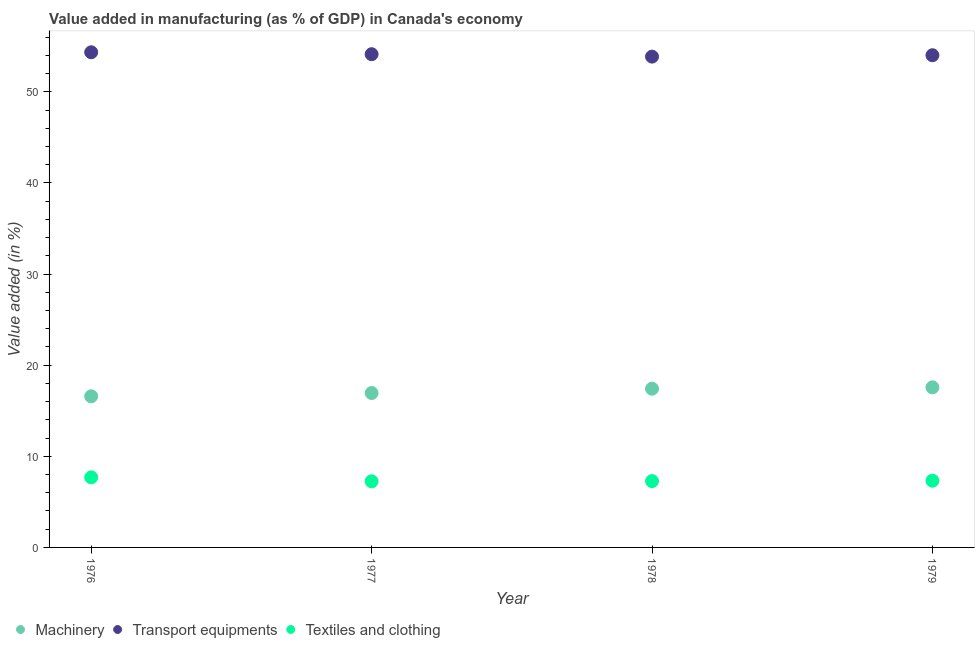How many different coloured dotlines are there?
Keep it short and to the point. 3. Is the number of dotlines equal to the number of legend labels?
Provide a succinct answer. Yes. What is the value added in manufacturing transport equipments in 1979?
Offer a terse response. 54.01. Across all years, what is the maximum value added in manufacturing textile and clothing?
Offer a terse response. 7.69. Across all years, what is the minimum value added in manufacturing textile and clothing?
Provide a succinct answer. 7.26. In which year was the value added in manufacturing machinery maximum?
Give a very brief answer. 1979. In which year was the value added in manufacturing transport equipments minimum?
Offer a terse response. 1978. What is the total value added in manufacturing transport equipments in the graph?
Make the answer very short. 216.33. What is the difference between the value added in manufacturing transport equipments in 1978 and that in 1979?
Ensure brevity in your answer.  -0.15. What is the difference between the value added in manufacturing machinery in 1978 and the value added in manufacturing transport equipments in 1977?
Offer a terse response. -36.71. What is the average value added in manufacturing transport equipments per year?
Ensure brevity in your answer.  54.08. In the year 1979, what is the difference between the value added in manufacturing textile and clothing and value added in manufacturing transport equipments?
Your answer should be compact. -46.69. In how many years, is the value added in manufacturing textile and clothing greater than 48 %?
Give a very brief answer. 0. What is the ratio of the value added in manufacturing textile and clothing in 1976 to that in 1977?
Your response must be concise. 1.06. Is the value added in manufacturing machinery in 1976 less than that in 1977?
Your answer should be very brief. Yes. What is the difference between the highest and the second highest value added in manufacturing textile and clothing?
Offer a very short reply. 0.36. What is the difference between the highest and the lowest value added in manufacturing machinery?
Make the answer very short. 0.98. In how many years, is the value added in manufacturing transport equipments greater than the average value added in manufacturing transport equipments taken over all years?
Offer a very short reply. 2. Is the sum of the value added in manufacturing transport equipments in 1978 and 1979 greater than the maximum value added in manufacturing machinery across all years?
Your answer should be very brief. Yes. Is it the case that in every year, the sum of the value added in manufacturing machinery and value added in manufacturing transport equipments is greater than the value added in manufacturing textile and clothing?
Offer a terse response. Yes. Does the value added in manufacturing textile and clothing monotonically increase over the years?
Provide a succinct answer. No. Is the value added in manufacturing textile and clothing strictly greater than the value added in manufacturing machinery over the years?
Provide a succinct answer. No. How many years are there in the graph?
Your answer should be compact. 4. What is the difference between two consecutive major ticks on the Y-axis?
Your answer should be compact. 10. Are the values on the major ticks of Y-axis written in scientific E-notation?
Ensure brevity in your answer.  No. Where does the legend appear in the graph?
Ensure brevity in your answer.  Bottom left. How are the legend labels stacked?
Make the answer very short. Horizontal. What is the title of the graph?
Provide a short and direct response. Value added in manufacturing (as % of GDP) in Canada's economy. What is the label or title of the Y-axis?
Ensure brevity in your answer.  Value added (in %). What is the Value added (in %) in Machinery in 1976?
Give a very brief answer. 16.59. What is the Value added (in %) of Transport equipments in 1976?
Offer a very short reply. 54.34. What is the Value added (in %) in Textiles and clothing in 1976?
Make the answer very short. 7.69. What is the Value added (in %) of Machinery in 1977?
Give a very brief answer. 16.94. What is the Value added (in %) of Transport equipments in 1977?
Your answer should be compact. 54.13. What is the Value added (in %) in Textiles and clothing in 1977?
Offer a terse response. 7.26. What is the Value added (in %) of Machinery in 1978?
Your answer should be very brief. 17.42. What is the Value added (in %) in Transport equipments in 1978?
Ensure brevity in your answer.  53.86. What is the Value added (in %) of Textiles and clothing in 1978?
Offer a terse response. 7.28. What is the Value added (in %) in Machinery in 1979?
Give a very brief answer. 17.57. What is the Value added (in %) in Transport equipments in 1979?
Ensure brevity in your answer.  54.01. What is the Value added (in %) of Textiles and clothing in 1979?
Your answer should be compact. 7.32. Across all years, what is the maximum Value added (in %) in Machinery?
Provide a succinct answer. 17.57. Across all years, what is the maximum Value added (in %) in Transport equipments?
Make the answer very short. 54.34. Across all years, what is the maximum Value added (in %) of Textiles and clothing?
Keep it short and to the point. 7.69. Across all years, what is the minimum Value added (in %) in Machinery?
Give a very brief answer. 16.59. Across all years, what is the minimum Value added (in %) in Transport equipments?
Offer a very short reply. 53.86. Across all years, what is the minimum Value added (in %) in Textiles and clothing?
Provide a succinct answer. 7.26. What is the total Value added (in %) of Machinery in the graph?
Offer a very short reply. 68.52. What is the total Value added (in %) of Transport equipments in the graph?
Provide a succinct answer. 216.33. What is the total Value added (in %) in Textiles and clothing in the graph?
Keep it short and to the point. 29.54. What is the difference between the Value added (in %) of Machinery in 1976 and that in 1977?
Make the answer very short. -0.36. What is the difference between the Value added (in %) of Transport equipments in 1976 and that in 1977?
Ensure brevity in your answer.  0.21. What is the difference between the Value added (in %) in Textiles and clothing in 1976 and that in 1977?
Keep it short and to the point. 0.43. What is the difference between the Value added (in %) in Machinery in 1976 and that in 1978?
Ensure brevity in your answer.  -0.83. What is the difference between the Value added (in %) of Transport equipments in 1976 and that in 1978?
Your answer should be very brief. 0.48. What is the difference between the Value added (in %) of Textiles and clothing in 1976 and that in 1978?
Keep it short and to the point. 0.41. What is the difference between the Value added (in %) of Machinery in 1976 and that in 1979?
Give a very brief answer. -0.98. What is the difference between the Value added (in %) of Transport equipments in 1976 and that in 1979?
Ensure brevity in your answer.  0.32. What is the difference between the Value added (in %) of Textiles and clothing in 1976 and that in 1979?
Give a very brief answer. 0.36. What is the difference between the Value added (in %) of Machinery in 1977 and that in 1978?
Offer a very short reply. -0.48. What is the difference between the Value added (in %) in Transport equipments in 1977 and that in 1978?
Offer a very short reply. 0.27. What is the difference between the Value added (in %) in Textiles and clothing in 1977 and that in 1978?
Your answer should be compact. -0.02. What is the difference between the Value added (in %) of Machinery in 1977 and that in 1979?
Your response must be concise. -0.62. What is the difference between the Value added (in %) of Transport equipments in 1977 and that in 1979?
Offer a very short reply. 0.11. What is the difference between the Value added (in %) of Textiles and clothing in 1977 and that in 1979?
Provide a short and direct response. -0.07. What is the difference between the Value added (in %) in Machinery in 1978 and that in 1979?
Provide a succinct answer. -0.15. What is the difference between the Value added (in %) in Transport equipments in 1978 and that in 1979?
Give a very brief answer. -0.15. What is the difference between the Value added (in %) of Textiles and clothing in 1978 and that in 1979?
Provide a short and direct response. -0.05. What is the difference between the Value added (in %) of Machinery in 1976 and the Value added (in %) of Transport equipments in 1977?
Ensure brevity in your answer.  -37.54. What is the difference between the Value added (in %) in Machinery in 1976 and the Value added (in %) in Textiles and clothing in 1977?
Make the answer very short. 9.33. What is the difference between the Value added (in %) in Transport equipments in 1976 and the Value added (in %) in Textiles and clothing in 1977?
Offer a terse response. 47.08. What is the difference between the Value added (in %) in Machinery in 1976 and the Value added (in %) in Transport equipments in 1978?
Your answer should be very brief. -37.27. What is the difference between the Value added (in %) of Machinery in 1976 and the Value added (in %) of Textiles and clothing in 1978?
Make the answer very short. 9.31. What is the difference between the Value added (in %) in Transport equipments in 1976 and the Value added (in %) in Textiles and clothing in 1978?
Offer a very short reply. 47.06. What is the difference between the Value added (in %) of Machinery in 1976 and the Value added (in %) of Transport equipments in 1979?
Keep it short and to the point. -37.43. What is the difference between the Value added (in %) of Machinery in 1976 and the Value added (in %) of Textiles and clothing in 1979?
Your answer should be compact. 9.26. What is the difference between the Value added (in %) of Transport equipments in 1976 and the Value added (in %) of Textiles and clothing in 1979?
Offer a very short reply. 47.01. What is the difference between the Value added (in %) of Machinery in 1977 and the Value added (in %) of Transport equipments in 1978?
Your answer should be very brief. -36.91. What is the difference between the Value added (in %) of Machinery in 1977 and the Value added (in %) of Textiles and clothing in 1978?
Offer a very short reply. 9.67. What is the difference between the Value added (in %) in Transport equipments in 1977 and the Value added (in %) in Textiles and clothing in 1978?
Your response must be concise. 46.85. What is the difference between the Value added (in %) of Machinery in 1977 and the Value added (in %) of Transport equipments in 1979?
Your answer should be compact. -37.07. What is the difference between the Value added (in %) in Machinery in 1977 and the Value added (in %) in Textiles and clothing in 1979?
Your answer should be compact. 9.62. What is the difference between the Value added (in %) in Transport equipments in 1977 and the Value added (in %) in Textiles and clothing in 1979?
Offer a terse response. 46.8. What is the difference between the Value added (in %) in Machinery in 1978 and the Value added (in %) in Transport equipments in 1979?
Your response must be concise. -36.59. What is the difference between the Value added (in %) of Machinery in 1978 and the Value added (in %) of Textiles and clothing in 1979?
Your response must be concise. 10.1. What is the difference between the Value added (in %) of Transport equipments in 1978 and the Value added (in %) of Textiles and clothing in 1979?
Give a very brief answer. 46.54. What is the average Value added (in %) of Machinery per year?
Your answer should be very brief. 17.13. What is the average Value added (in %) in Transport equipments per year?
Make the answer very short. 54.08. What is the average Value added (in %) in Textiles and clothing per year?
Give a very brief answer. 7.39. In the year 1976, what is the difference between the Value added (in %) in Machinery and Value added (in %) in Transport equipments?
Your response must be concise. -37.75. In the year 1976, what is the difference between the Value added (in %) of Machinery and Value added (in %) of Textiles and clothing?
Give a very brief answer. 8.9. In the year 1976, what is the difference between the Value added (in %) of Transport equipments and Value added (in %) of Textiles and clothing?
Provide a succinct answer. 46.65. In the year 1977, what is the difference between the Value added (in %) in Machinery and Value added (in %) in Transport equipments?
Offer a very short reply. -37.18. In the year 1977, what is the difference between the Value added (in %) of Machinery and Value added (in %) of Textiles and clothing?
Your answer should be compact. 9.69. In the year 1977, what is the difference between the Value added (in %) of Transport equipments and Value added (in %) of Textiles and clothing?
Give a very brief answer. 46.87. In the year 1978, what is the difference between the Value added (in %) of Machinery and Value added (in %) of Transport equipments?
Keep it short and to the point. -36.44. In the year 1978, what is the difference between the Value added (in %) of Machinery and Value added (in %) of Textiles and clothing?
Ensure brevity in your answer.  10.14. In the year 1978, what is the difference between the Value added (in %) of Transport equipments and Value added (in %) of Textiles and clothing?
Your answer should be compact. 46.58. In the year 1979, what is the difference between the Value added (in %) of Machinery and Value added (in %) of Transport equipments?
Provide a succinct answer. -36.44. In the year 1979, what is the difference between the Value added (in %) of Machinery and Value added (in %) of Textiles and clothing?
Your answer should be very brief. 10.25. In the year 1979, what is the difference between the Value added (in %) of Transport equipments and Value added (in %) of Textiles and clothing?
Your answer should be very brief. 46.69. What is the ratio of the Value added (in %) of Machinery in 1976 to that in 1977?
Your answer should be very brief. 0.98. What is the ratio of the Value added (in %) of Transport equipments in 1976 to that in 1977?
Provide a succinct answer. 1. What is the ratio of the Value added (in %) of Textiles and clothing in 1976 to that in 1977?
Ensure brevity in your answer.  1.06. What is the ratio of the Value added (in %) of Machinery in 1976 to that in 1978?
Keep it short and to the point. 0.95. What is the ratio of the Value added (in %) of Transport equipments in 1976 to that in 1978?
Give a very brief answer. 1.01. What is the ratio of the Value added (in %) of Textiles and clothing in 1976 to that in 1978?
Offer a terse response. 1.06. What is the ratio of the Value added (in %) of Machinery in 1976 to that in 1979?
Your answer should be very brief. 0.94. What is the ratio of the Value added (in %) of Transport equipments in 1976 to that in 1979?
Provide a succinct answer. 1.01. What is the ratio of the Value added (in %) in Textiles and clothing in 1976 to that in 1979?
Give a very brief answer. 1.05. What is the ratio of the Value added (in %) of Machinery in 1977 to that in 1978?
Your response must be concise. 0.97. What is the ratio of the Value added (in %) of Transport equipments in 1977 to that in 1978?
Give a very brief answer. 1. What is the ratio of the Value added (in %) of Textiles and clothing in 1977 to that in 1978?
Ensure brevity in your answer.  1. What is the ratio of the Value added (in %) of Machinery in 1977 to that in 1979?
Offer a terse response. 0.96. What is the ratio of the Value added (in %) of Transport equipments in 1977 to that in 1979?
Make the answer very short. 1. What is the ratio of the Value added (in %) of Textiles and clothing in 1977 to that in 1979?
Your answer should be compact. 0.99. What is the ratio of the Value added (in %) in Machinery in 1978 to that in 1979?
Offer a very short reply. 0.99. What is the ratio of the Value added (in %) in Transport equipments in 1978 to that in 1979?
Ensure brevity in your answer.  1. What is the difference between the highest and the second highest Value added (in %) in Machinery?
Keep it short and to the point. 0.15. What is the difference between the highest and the second highest Value added (in %) of Transport equipments?
Your answer should be compact. 0.21. What is the difference between the highest and the second highest Value added (in %) in Textiles and clothing?
Offer a very short reply. 0.36. What is the difference between the highest and the lowest Value added (in %) of Machinery?
Offer a terse response. 0.98. What is the difference between the highest and the lowest Value added (in %) of Transport equipments?
Provide a short and direct response. 0.48. What is the difference between the highest and the lowest Value added (in %) of Textiles and clothing?
Your response must be concise. 0.43. 